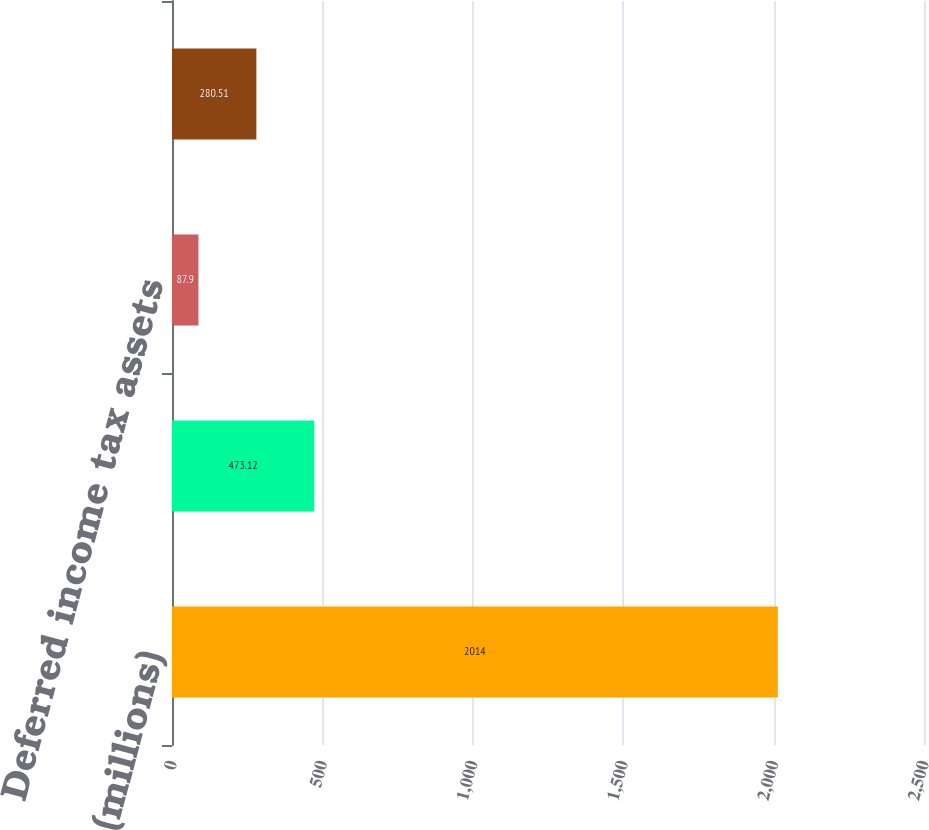<chart> <loc_0><loc_0><loc_500><loc_500><bar_chart><fcel>(millions)<fcel>Accrued pension liability<fcel>Deferred income tax assets<fcel>Accumulated other<nl><fcel>2014<fcel>473.12<fcel>87.9<fcel>280.51<nl></chart> 